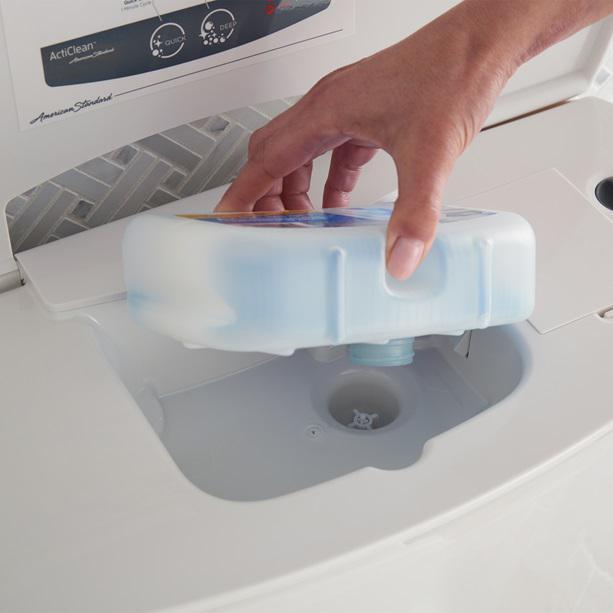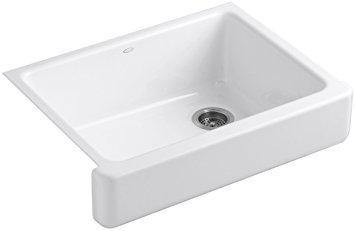The first image is the image on the left, the second image is the image on the right. For the images displayed, is the sentence "the sinks is square in the right pic" factually correct? Answer yes or no. Yes. 